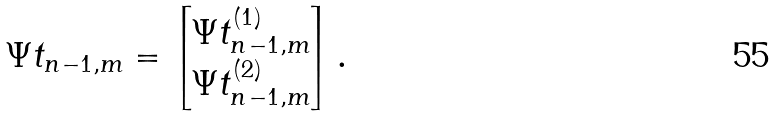<formula> <loc_0><loc_0><loc_500><loc_500>\Psi t _ { n - 1 , m } = \left [ \begin{matrix} \Psi t _ { n - 1 , m } ^ { ( 1 ) } \\ \Psi t _ { n - 1 , m } ^ { ( 2 ) } \end{matrix} \right ] .</formula> 